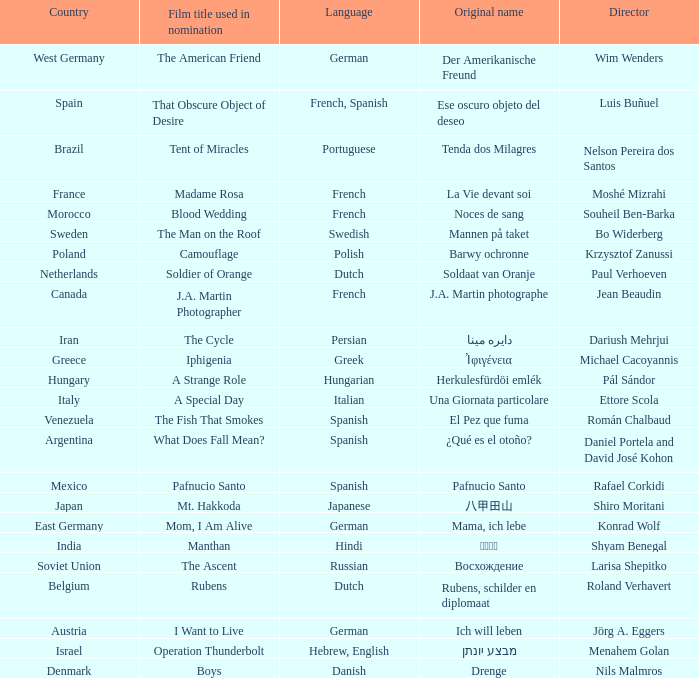Which country is the film Tent of Miracles from? Brazil. 